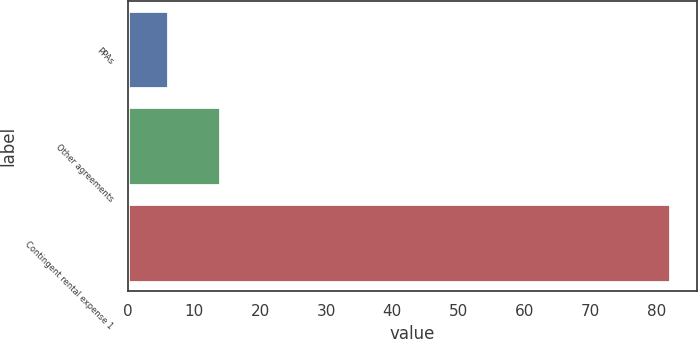<chart> <loc_0><loc_0><loc_500><loc_500><bar_chart><fcel>PPAs<fcel>Other agreements<fcel>Contingent rental expense 1<nl><fcel>6<fcel>14<fcel>82<nl></chart> 